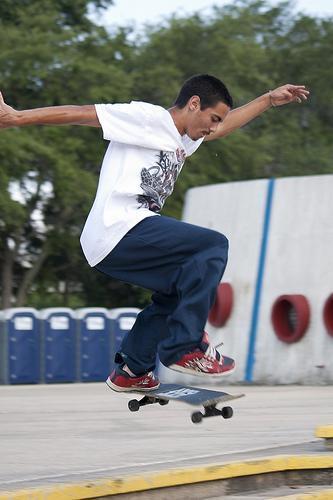How many people are in the photo?
Give a very brief answer. 1. 